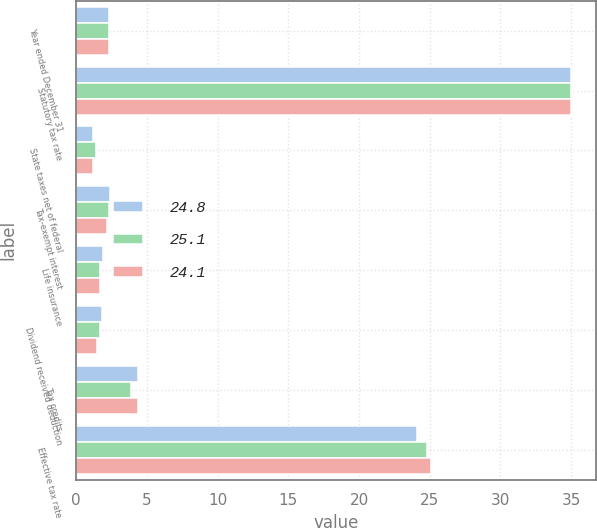Convert chart to OTSL. <chart><loc_0><loc_0><loc_500><loc_500><stacked_bar_chart><ecel><fcel>Year ended December 31<fcel>Statutory tax rate<fcel>State taxes net of federal<fcel>Tax-exempt interest<fcel>Life insurance<fcel>Dividend received deduction<fcel>Tax credits<fcel>Effective tax rate<nl><fcel>24.8<fcel>2.3<fcel>35<fcel>1.2<fcel>2.4<fcel>1.9<fcel>1.8<fcel>4.4<fcel>24.1<nl><fcel>25.1<fcel>2.3<fcel>35<fcel>1.4<fcel>2.3<fcel>1.7<fcel>1.7<fcel>3.9<fcel>24.8<nl><fcel>24.1<fcel>2.3<fcel>35<fcel>1.2<fcel>2.2<fcel>1.7<fcel>1.5<fcel>4.4<fcel>25.1<nl></chart> 